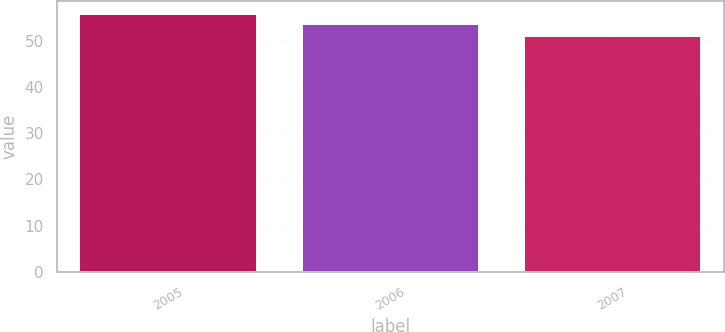Convert chart. <chart><loc_0><loc_0><loc_500><loc_500><bar_chart><fcel>2005<fcel>2006<fcel>2007<nl><fcel>55.85<fcel>53.68<fcel>51.06<nl></chart> 